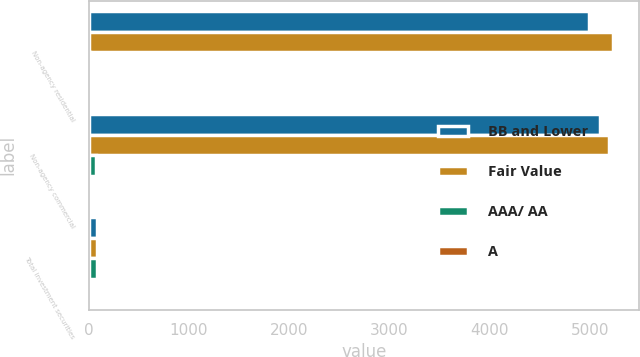Convert chart to OTSL. <chart><loc_0><loc_0><loc_500><loc_500><stacked_bar_chart><ecel><fcel>Non-agency residential<fcel>Non-agency commercial<fcel>Total investment securities<nl><fcel>BB and Lower<fcel>4993<fcel>5095<fcel>81<nl><fcel>Fair Value<fcel>5225<fcel>5191<fcel>81<nl><fcel>AAA/ AA<fcel>10<fcel>77<fcel>85<nl><fcel>A<fcel>1<fcel>7<fcel>2<nl></chart> 